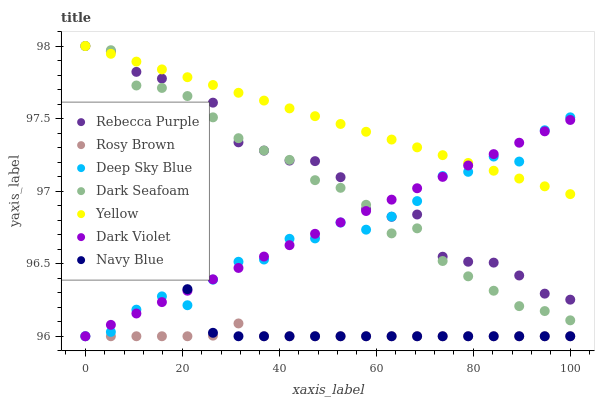Does Rosy Brown have the minimum area under the curve?
Answer yes or no. Yes. Does Yellow have the maximum area under the curve?
Answer yes or no. Yes. Does Dark Violet have the minimum area under the curve?
Answer yes or no. No. Does Dark Violet have the maximum area under the curve?
Answer yes or no. No. Is Dark Violet the smoothest?
Answer yes or no. Yes. Is Rebecca Purple the roughest?
Answer yes or no. Yes. Is Rosy Brown the smoothest?
Answer yes or no. No. Is Rosy Brown the roughest?
Answer yes or no. No. Does Navy Blue have the lowest value?
Answer yes or no. Yes. Does Dark Seafoam have the lowest value?
Answer yes or no. No. Does Rebecca Purple have the highest value?
Answer yes or no. Yes. Does Dark Violet have the highest value?
Answer yes or no. No. Is Navy Blue less than Dark Seafoam?
Answer yes or no. Yes. Is Dark Seafoam greater than Navy Blue?
Answer yes or no. Yes. Does Rebecca Purple intersect Dark Violet?
Answer yes or no. Yes. Is Rebecca Purple less than Dark Violet?
Answer yes or no. No. Is Rebecca Purple greater than Dark Violet?
Answer yes or no. No. Does Navy Blue intersect Dark Seafoam?
Answer yes or no. No. 